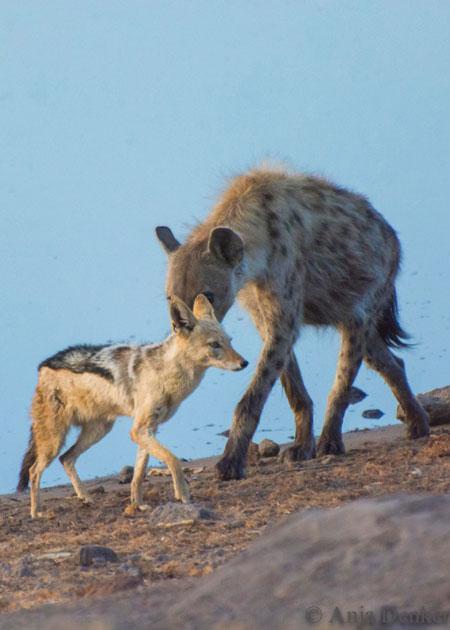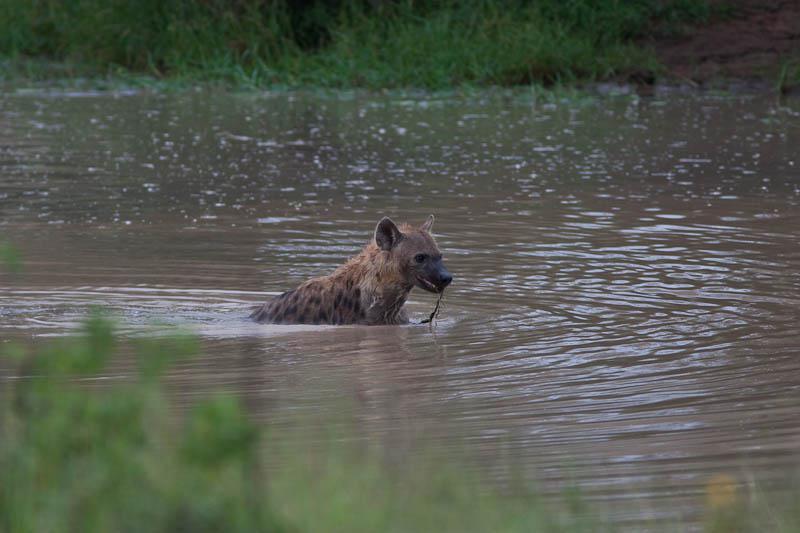The first image is the image on the left, the second image is the image on the right. Examine the images to the left and right. Is the description "All hyenas are in the water, and one image shows a single hyena, with its head facing the camera." accurate? Answer yes or no. No. The first image is the image on the left, the second image is the image on the right. Considering the images on both sides, is "The right image contains exactly one hyena wading through a body of water." valid? Answer yes or no. Yes. 